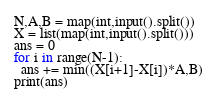<code> <loc_0><loc_0><loc_500><loc_500><_Python_>N,A,B = map(int,input().split())
X = list(map(int,input().split()))
ans = 0
for i in range(N-1):
  ans += min((X[i+1]-X[i])*A,B)
print(ans)</code> 